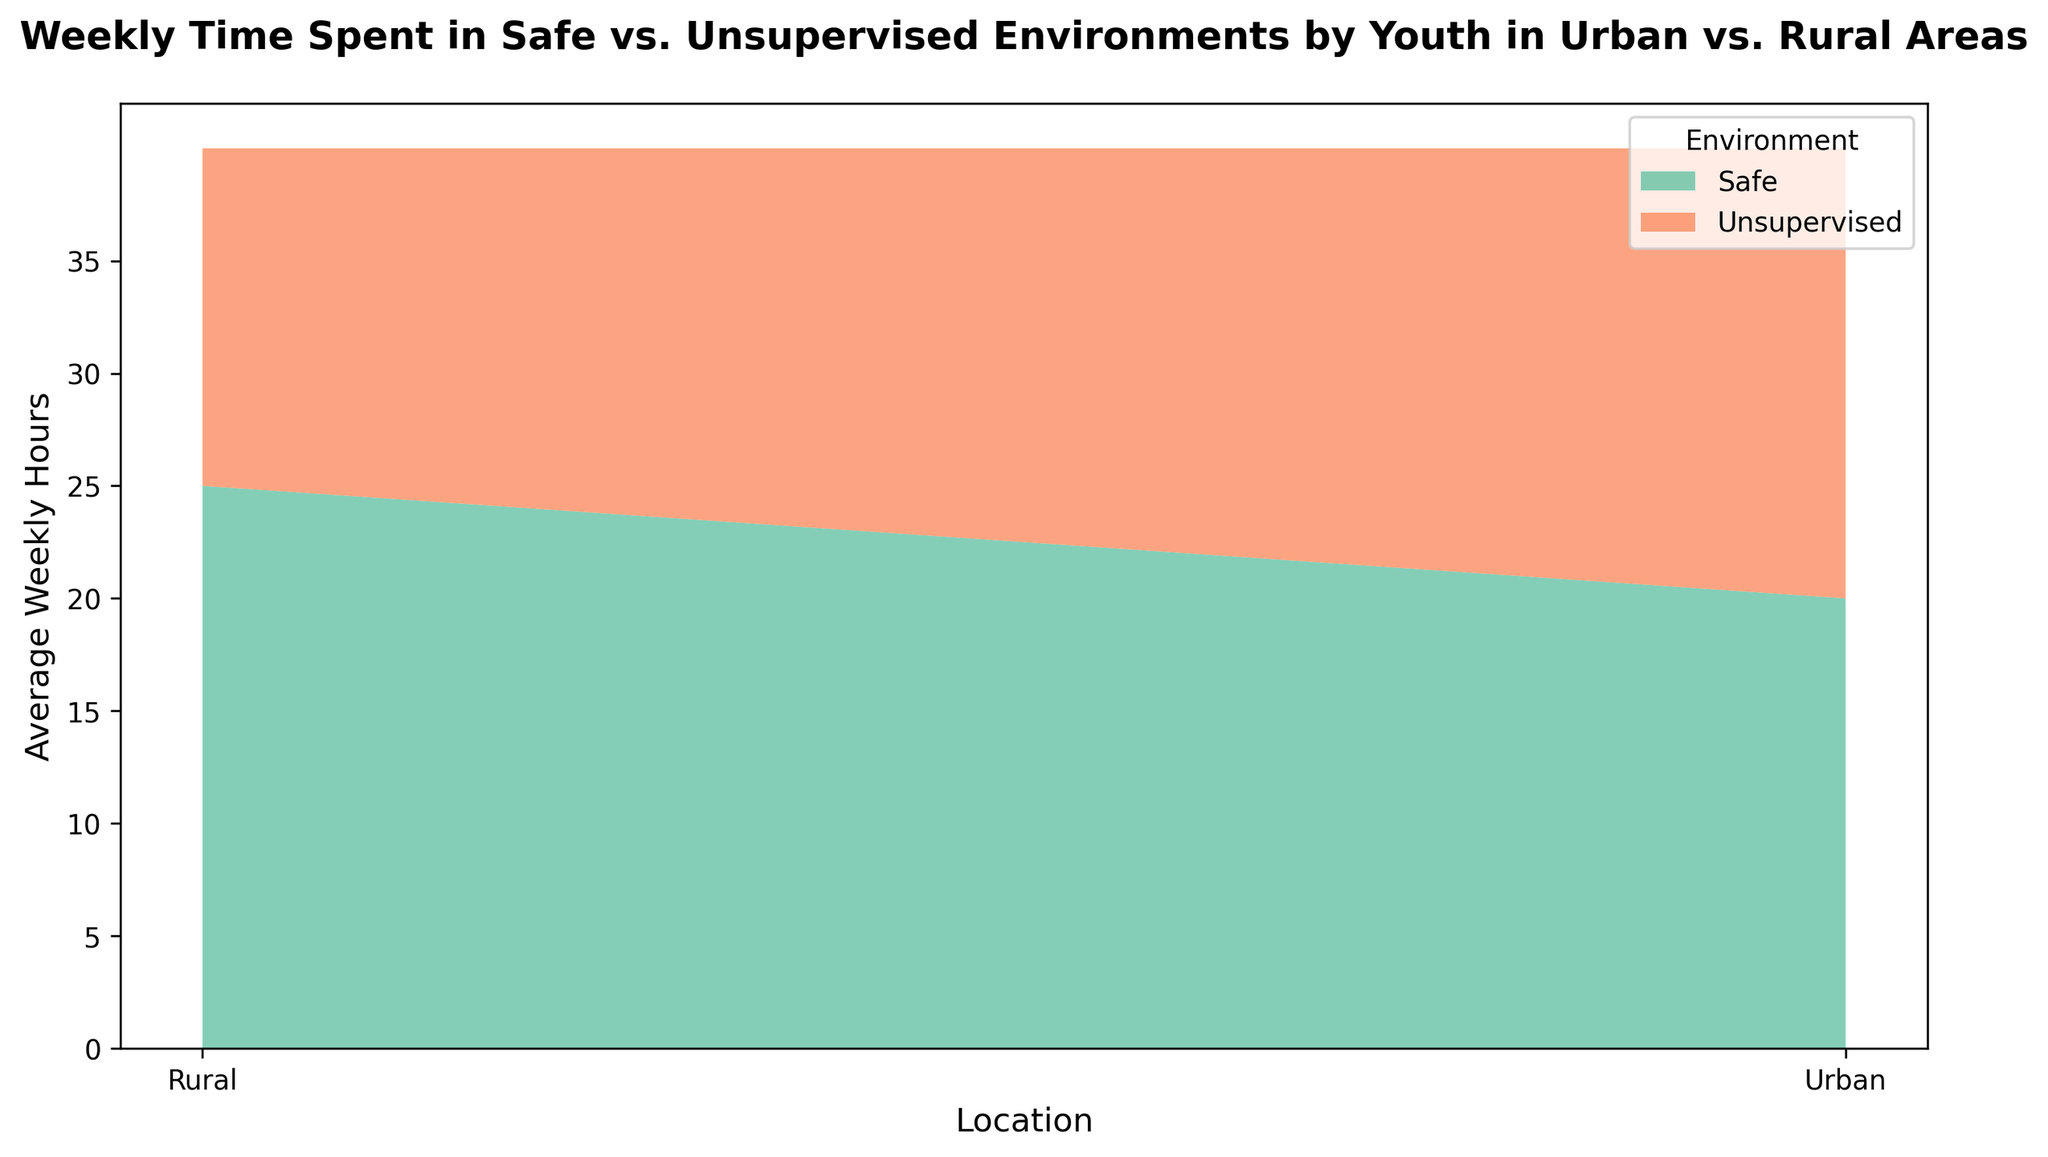What is the average weekly time spent in safe environments by urban youth? The figure shows a stacked area plot with average weekly hours. For urban youth, the safe environment is indicated in green, and the value can be directly read from the y-axis at the urban location. The average time is approximately 20 hours.
Answer: 20 hours How much more time do rural youth spend, on average, in safe environments compared to urban youth? The average weekly hours for rural youth in safe environments is about 25 hours, while for urban youth it is about 20 hours. The difference between them is 25 - 20 = 5 hours.
Answer: 5 hours Which environment has a higher average weekly time in rural areas? Comparing the two shaded areas for rural locations, the green area (safe environment) appears larger than the orange area (unsupervised environment). This indicates that the average weekly time spent in safe environments is higher.
Answer: Safe environments Is the average weekly time spent in unsupervised environments higher in urban or rural areas? By looking at the orange portions of the stacked areas for both urban and rural locations, we can see that the orange area in the urban section is larger, indicating higher average weekly hours.
Answer: Urban areas What is the sum of average weekly hours spent on both environments in urban areas? For urban youth, the average weekly hours spent in safe environments is about 20 hours, and in unsupervised environments, it is about 20 hours. Summing these values gives 20 + 20 = 40 hours.
Answer: 40 hours By how much does the time spent in unsupervised environments differ between rural and urban areas? The average weekly hours for unsupervised environments is about 15 hours for rural and about 20 hours for urban areas, leading to a difference of 20 - 15 = 5 hours.
Answer: 5 hours Which group spends the least average weekly time in unsupervised environments? By comparing the heights of the orange areas in the stacked plot, it is evident that rural youth spend the least time in unsupervised environments with an average of about 15 hours.
Answer: Rural youth How much total time is spent by rural youth in both environments per week on average? For rural youth, the average weekly hours spent in safe environments is about 25 hours, and in unsupervised environments, it is about 15 hours. Adding these together gives 25 + 15 = 40 hours.
Answer: 40 hours 